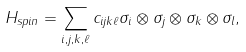<formula> <loc_0><loc_0><loc_500><loc_500>H _ { s p i n } = \sum _ { i , j , k , \ell } c _ { i j k \ell } \sigma _ { i } \otimes \sigma _ { j } \otimes \sigma _ { k } \otimes \sigma _ { l } ,</formula> 